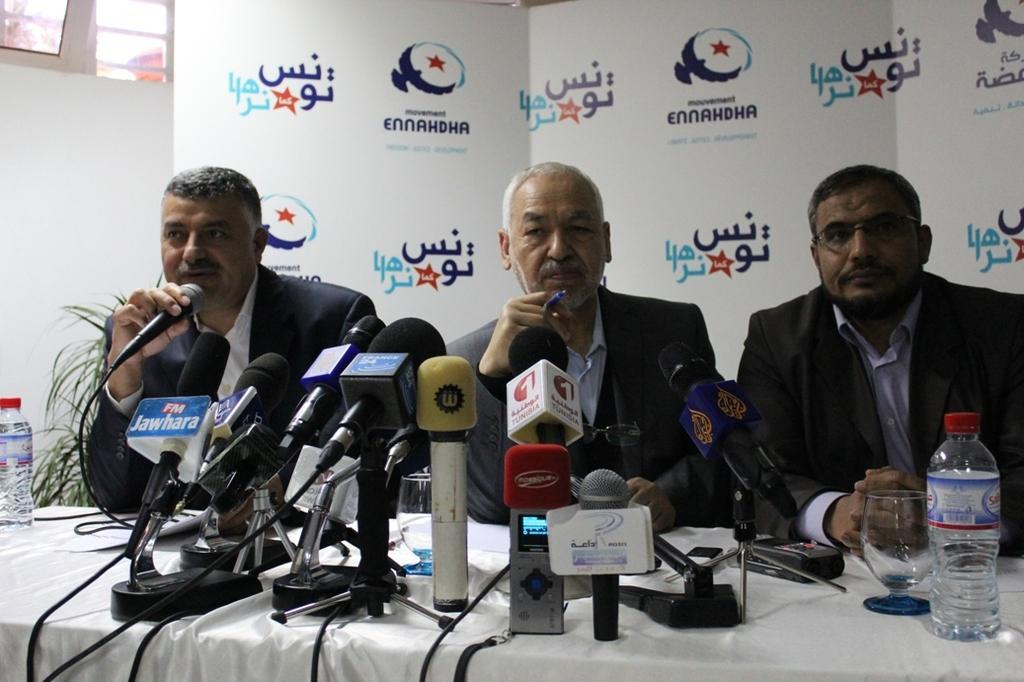Describe this image in one or two sentences. In this image I can see on the left side a man is sitting and speaking in the microphone, he wore coat. Beside him two other men are sitting. On the right side there is a wine glass and a water bottle. Behind them there is a white color board. 